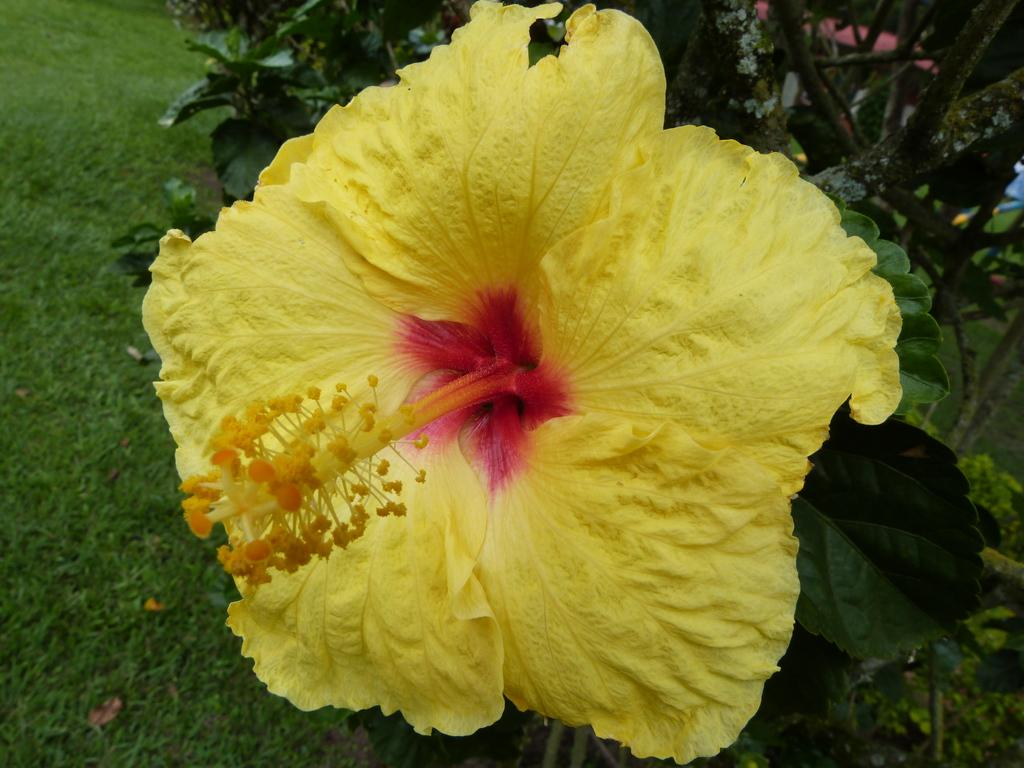What type of flower is in the image? There is a shoe flower in the image. What is the surface of the road made of in the image? There is grass on the road in the image. What can be seen on the right side of the image? There is a plant on the right side of the image. How does the zephyr affect the cork in the image? There is no cork or zephyr present in the image. 